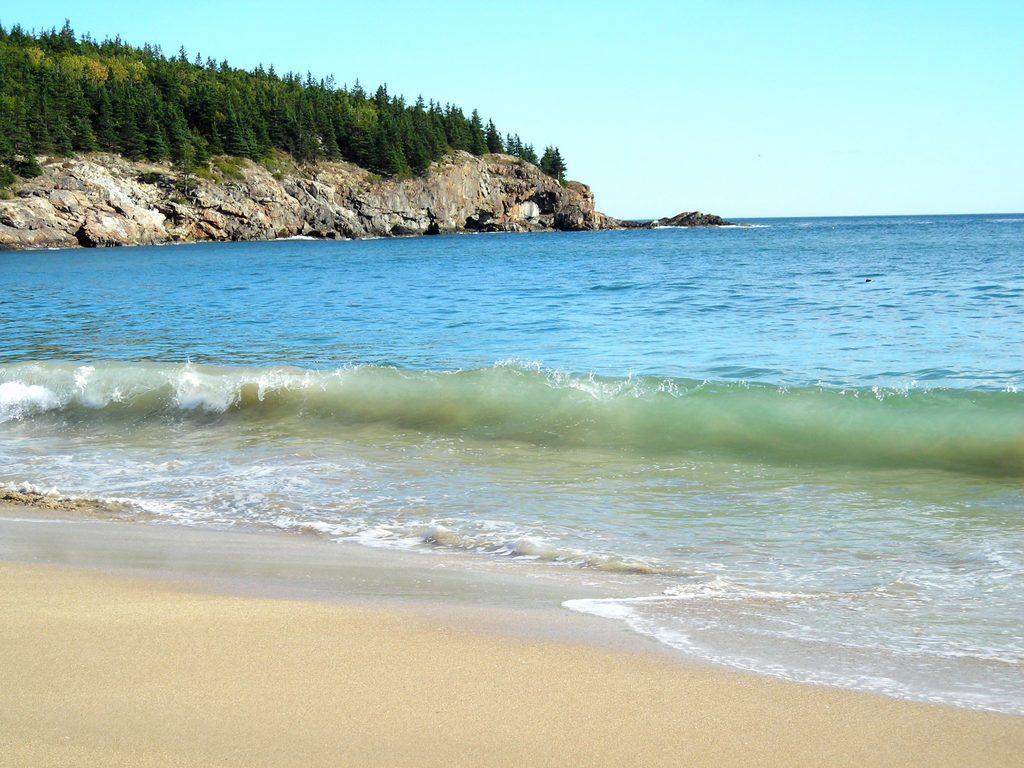How would you summarize this image in a sentence or two? In the center of the image we can see the ocean. In the background of the image we can see the mountains and trees. At the bottom of the image we can see the soil. At the top of the image we can see the sky. 